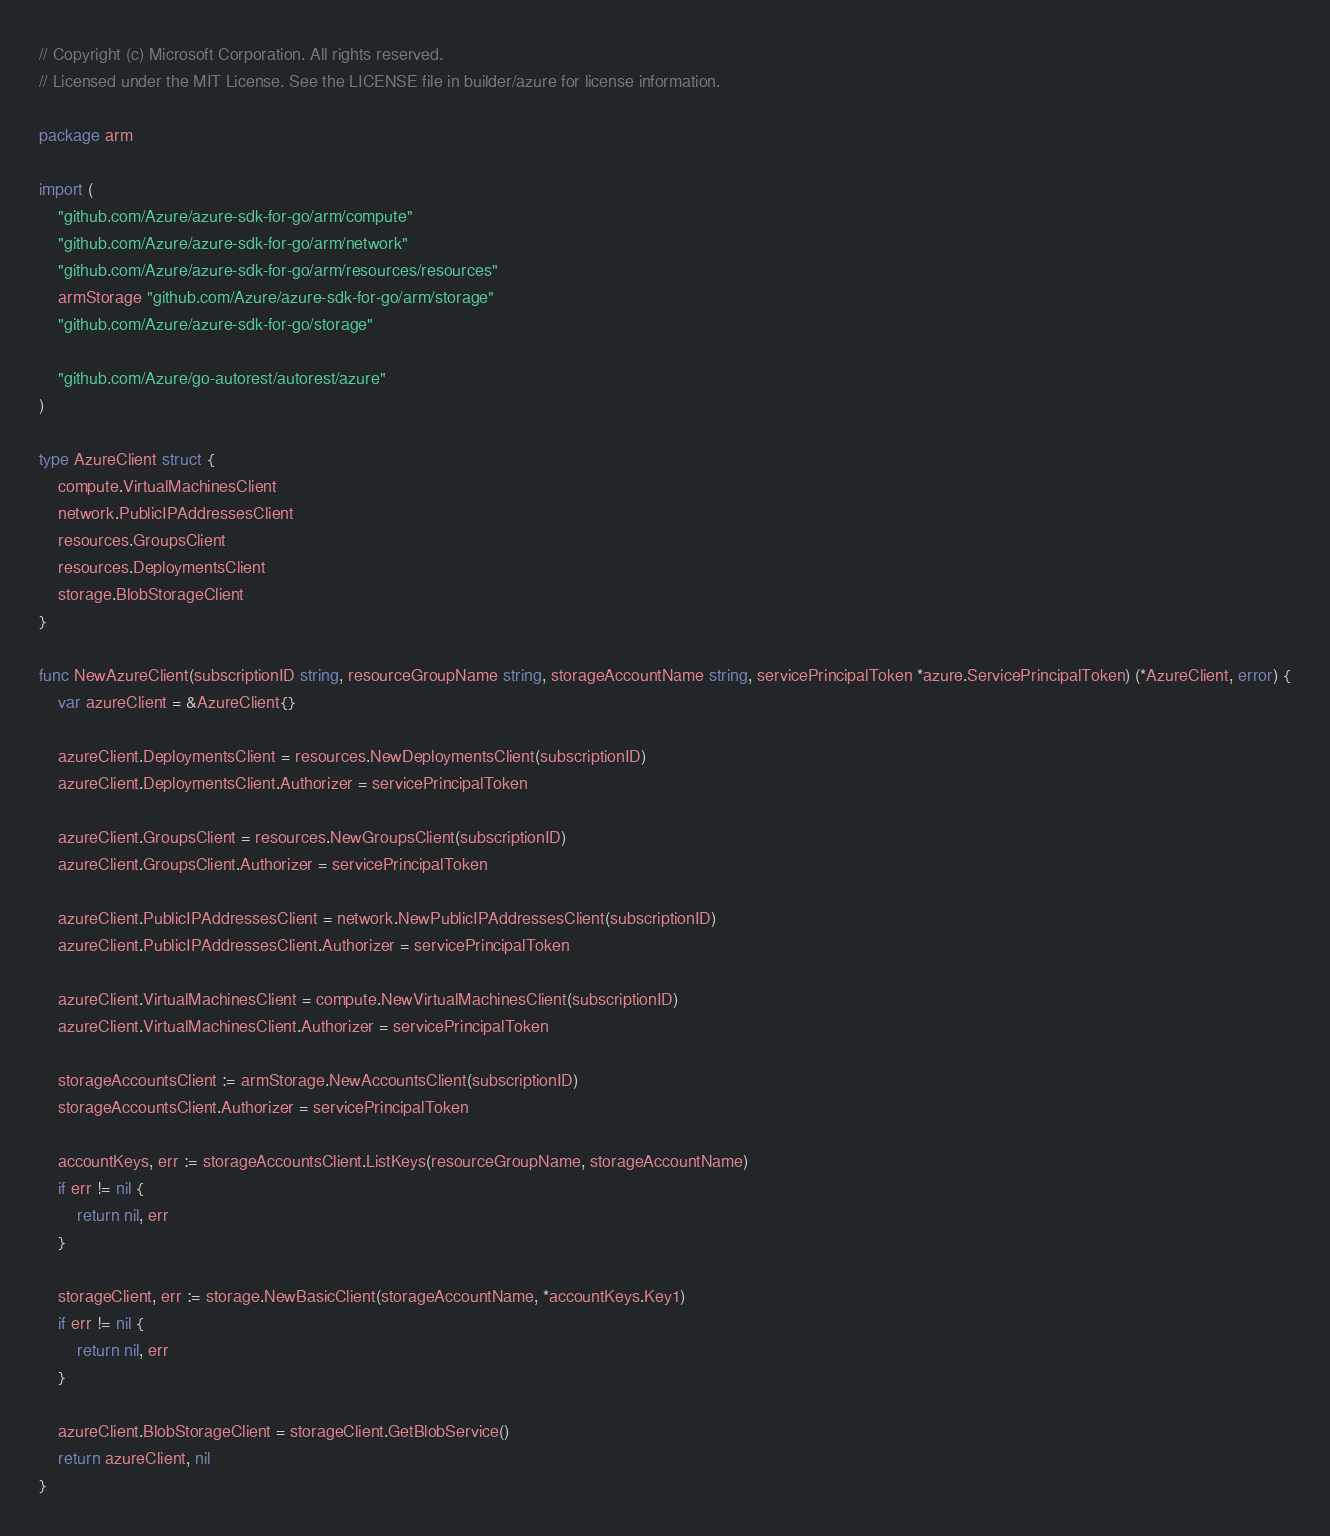Convert code to text. <code><loc_0><loc_0><loc_500><loc_500><_Go_>// Copyright (c) Microsoft Corporation. All rights reserved.
// Licensed under the MIT License. See the LICENSE file in builder/azure for license information.

package arm

import (
	"github.com/Azure/azure-sdk-for-go/arm/compute"
	"github.com/Azure/azure-sdk-for-go/arm/network"
	"github.com/Azure/azure-sdk-for-go/arm/resources/resources"
	armStorage "github.com/Azure/azure-sdk-for-go/arm/storage"
	"github.com/Azure/azure-sdk-for-go/storage"

	"github.com/Azure/go-autorest/autorest/azure"
)

type AzureClient struct {
	compute.VirtualMachinesClient
	network.PublicIPAddressesClient
	resources.GroupsClient
	resources.DeploymentsClient
	storage.BlobStorageClient
}

func NewAzureClient(subscriptionID string, resourceGroupName string, storageAccountName string, servicePrincipalToken *azure.ServicePrincipalToken) (*AzureClient, error) {
	var azureClient = &AzureClient{}

	azureClient.DeploymentsClient = resources.NewDeploymentsClient(subscriptionID)
	azureClient.DeploymentsClient.Authorizer = servicePrincipalToken

	azureClient.GroupsClient = resources.NewGroupsClient(subscriptionID)
	azureClient.GroupsClient.Authorizer = servicePrincipalToken

	azureClient.PublicIPAddressesClient = network.NewPublicIPAddressesClient(subscriptionID)
	azureClient.PublicIPAddressesClient.Authorizer = servicePrincipalToken

	azureClient.VirtualMachinesClient = compute.NewVirtualMachinesClient(subscriptionID)
	azureClient.VirtualMachinesClient.Authorizer = servicePrincipalToken

	storageAccountsClient := armStorage.NewAccountsClient(subscriptionID)
	storageAccountsClient.Authorizer = servicePrincipalToken

	accountKeys, err := storageAccountsClient.ListKeys(resourceGroupName, storageAccountName)
	if err != nil {
		return nil, err
	}

	storageClient, err := storage.NewBasicClient(storageAccountName, *accountKeys.Key1)
	if err != nil {
		return nil, err
	}

	azureClient.BlobStorageClient = storageClient.GetBlobService()
	return azureClient, nil
}
</code> 